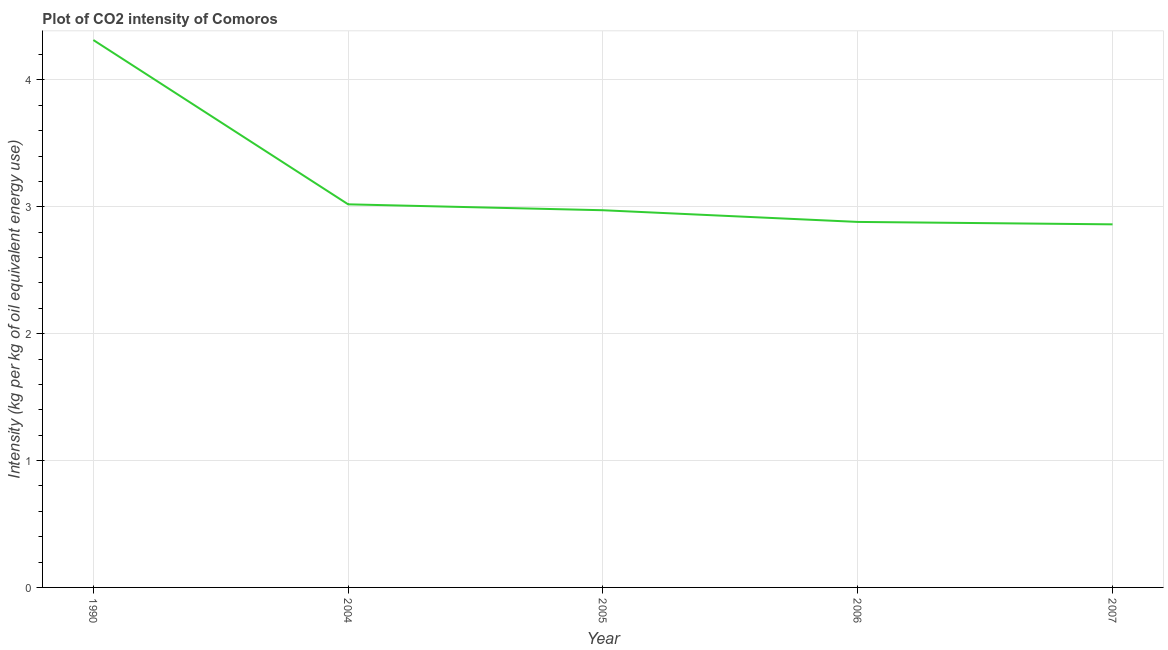What is the co2 intensity in 2004?
Offer a terse response. 3.02. Across all years, what is the maximum co2 intensity?
Provide a succinct answer. 4.31. Across all years, what is the minimum co2 intensity?
Offer a very short reply. 2.86. What is the sum of the co2 intensity?
Ensure brevity in your answer.  16.05. What is the difference between the co2 intensity in 1990 and 2004?
Ensure brevity in your answer.  1.3. What is the average co2 intensity per year?
Your answer should be compact. 3.21. What is the median co2 intensity?
Provide a short and direct response. 2.97. Do a majority of the years between 2006 and 2005 (inclusive) have co2 intensity greater than 2.4 kg?
Keep it short and to the point. No. What is the ratio of the co2 intensity in 2005 to that in 2006?
Give a very brief answer. 1.03. Is the co2 intensity in 2005 less than that in 2006?
Keep it short and to the point. No. Is the difference between the co2 intensity in 2006 and 2007 greater than the difference between any two years?
Keep it short and to the point. No. What is the difference between the highest and the second highest co2 intensity?
Your answer should be very brief. 1.3. Is the sum of the co2 intensity in 2004 and 2005 greater than the maximum co2 intensity across all years?
Ensure brevity in your answer.  Yes. What is the difference between the highest and the lowest co2 intensity?
Offer a very short reply. 1.45. In how many years, is the co2 intensity greater than the average co2 intensity taken over all years?
Your response must be concise. 1. Does the co2 intensity monotonically increase over the years?
Offer a terse response. No. How many lines are there?
Keep it short and to the point. 1. What is the difference between two consecutive major ticks on the Y-axis?
Your answer should be compact. 1. Are the values on the major ticks of Y-axis written in scientific E-notation?
Provide a succinct answer. No. Does the graph contain any zero values?
Keep it short and to the point. No. Does the graph contain grids?
Give a very brief answer. Yes. What is the title of the graph?
Your answer should be compact. Plot of CO2 intensity of Comoros. What is the label or title of the X-axis?
Give a very brief answer. Year. What is the label or title of the Y-axis?
Offer a very short reply. Intensity (kg per kg of oil equivalent energy use). What is the Intensity (kg per kg of oil equivalent energy use) of 1990?
Your answer should be very brief. 4.31. What is the Intensity (kg per kg of oil equivalent energy use) of 2004?
Your response must be concise. 3.02. What is the Intensity (kg per kg of oil equivalent energy use) in 2005?
Make the answer very short. 2.97. What is the Intensity (kg per kg of oil equivalent energy use) in 2006?
Offer a terse response. 2.88. What is the Intensity (kg per kg of oil equivalent energy use) in 2007?
Your response must be concise. 2.86. What is the difference between the Intensity (kg per kg of oil equivalent energy use) in 1990 and 2004?
Offer a very short reply. 1.3. What is the difference between the Intensity (kg per kg of oil equivalent energy use) in 1990 and 2005?
Offer a terse response. 1.34. What is the difference between the Intensity (kg per kg of oil equivalent energy use) in 1990 and 2006?
Offer a terse response. 1.43. What is the difference between the Intensity (kg per kg of oil equivalent energy use) in 1990 and 2007?
Your response must be concise. 1.45. What is the difference between the Intensity (kg per kg of oil equivalent energy use) in 2004 and 2005?
Your answer should be very brief. 0.05. What is the difference between the Intensity (kg per kg of oil equivalent energy use) in 2004 and 2006?
Your answer should be very brief. 0.14. What is the difference between the Intensity (kg per kg of oil equivalent energy use) in 2004 and 2007?
Keep it short and to the point. 0.16. What is the difference between the Intensity (kg per kg of oil equivalent energy use) in 2005 and 2006?
Your answer should be very brief. 0.09. What is the difference between the Intensity (kg per kg of oil equivalent energy use) in 2005 and 2007?
Your answer should be very brief. 0.11. What is the difference between the Intensity (kg per kg of oil equivalent energy use) in 2006 and 2007?
Ensure brevity in your answer.  0.02. What is the ratio of the Intensity (kg per kg of oil equivalent energy use) in 1990 to that in 2004?
Your response must be concise. 1.43. What is the ratio of the Intensity (kg per kg of oil equivalent energy use) in 1990 to that in 2005?
Your response must be concise. 1.45. What is the ratio of the Intensity (kg per kg of oil equivalent energy use) in 1990 to that in 2006?
Offer a very short reply. 1.5. What is the ratio of the Intensity (kg per kg of oil equivalent energy use) in 1990 to that in 2007?
Your answer should be compact. 1.51. What is the ratio of the Intensity (kg per kg of oil equivalent energy use) in 2004 to that in 2006?
Keep it short and to the point. 1.05. What is the ratio of the Intensity (kg per kg of oil equivalent energy use) in 2004 to that in 2007?
Offer a terse response. 1.05. What is the ratio of the Intensity (kg per kg of oil equivalent energy use) in 2005 to that in 2006?
Keep it short and to the point. 1.03. What is the ratio of the Intensity (kg per kg of oil equivalent energy use) in 2005 to that in 2007?
Keep it short and to the point. 1.04. 